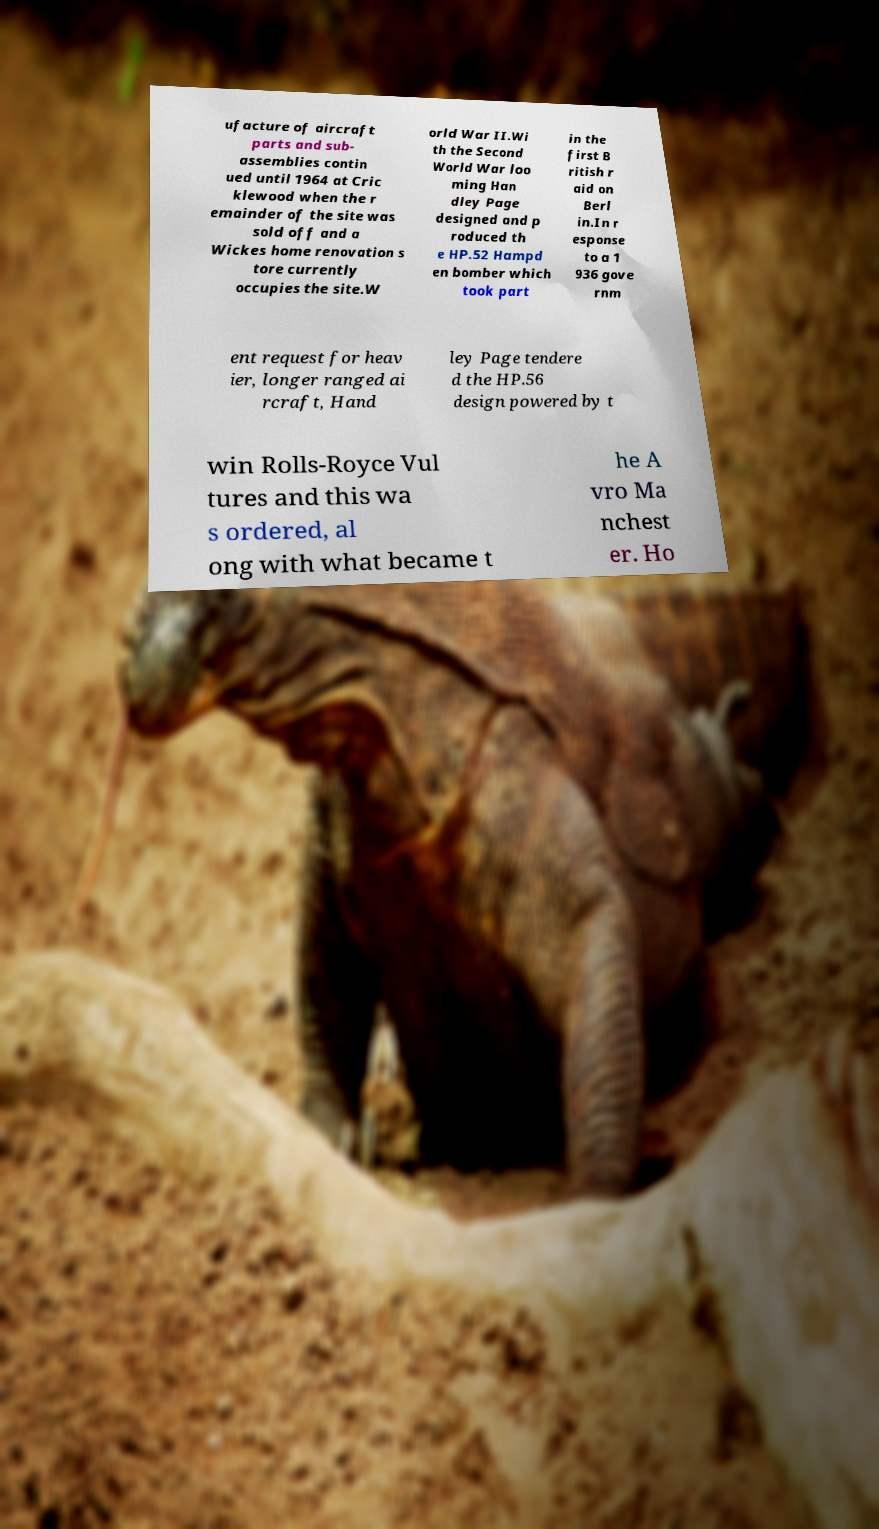Could you extract and type out the text from this image? ufacture of aircraft parts and sub- assemblies contin ued until 1964 at Cric klewood when the r emainder of the site was sold off and a Wickes home renovation s tore currently occupies the site.W orld War II.Wi th the Second World War loo ming Han dley Page designed and p roduced th e HP.52 Hampd en bomber which took part in the first B ritish r aid on Berl in.In r esponse to a 1 936 gove rnm ent request for heav ier, longer ranged ai rcraft, Hand ley Page tendere d the HP.56 design powered by t win Rolls-Royce Vul tures and this wa s ordered, al ong with what became t he A vro Ma nchest er. Ho 